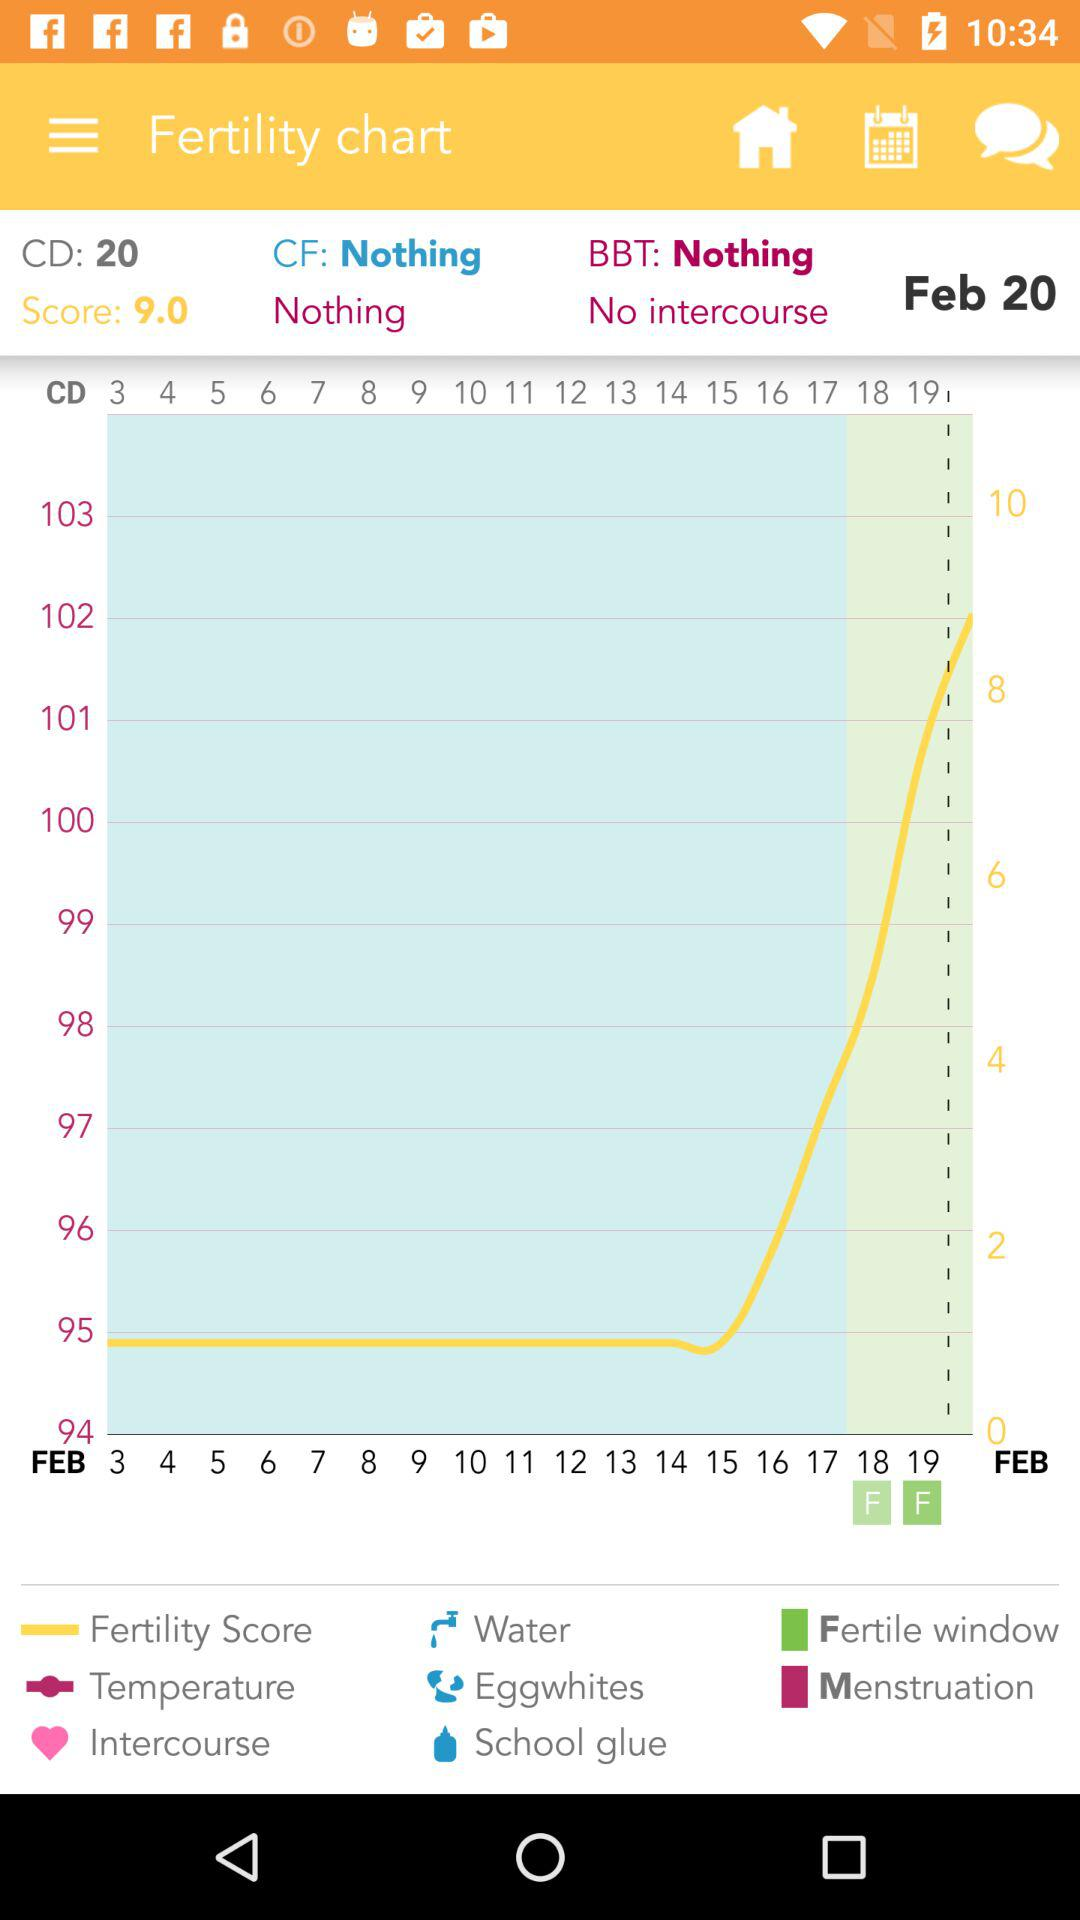What is the score? The score is 9.0. 